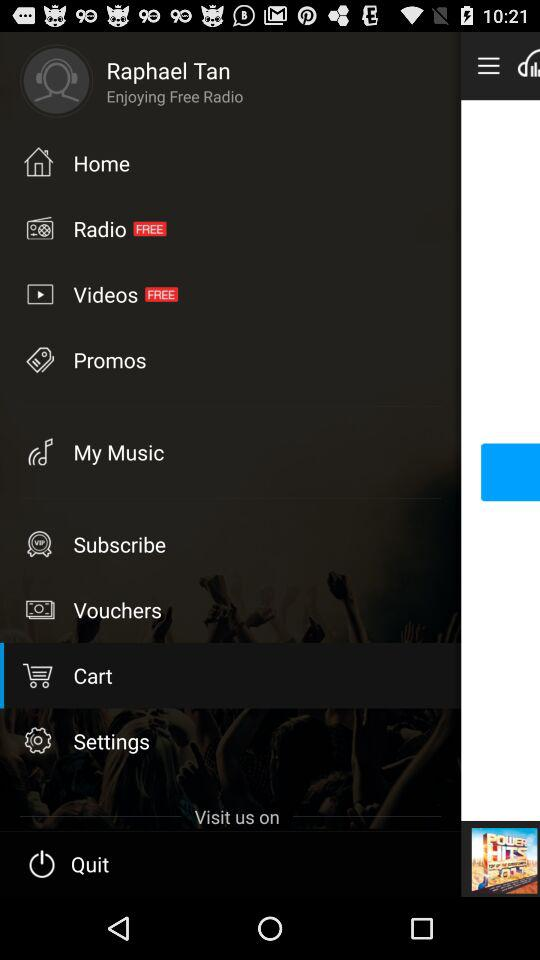What is the name of the user? The name of the user is Raphael Tan. 